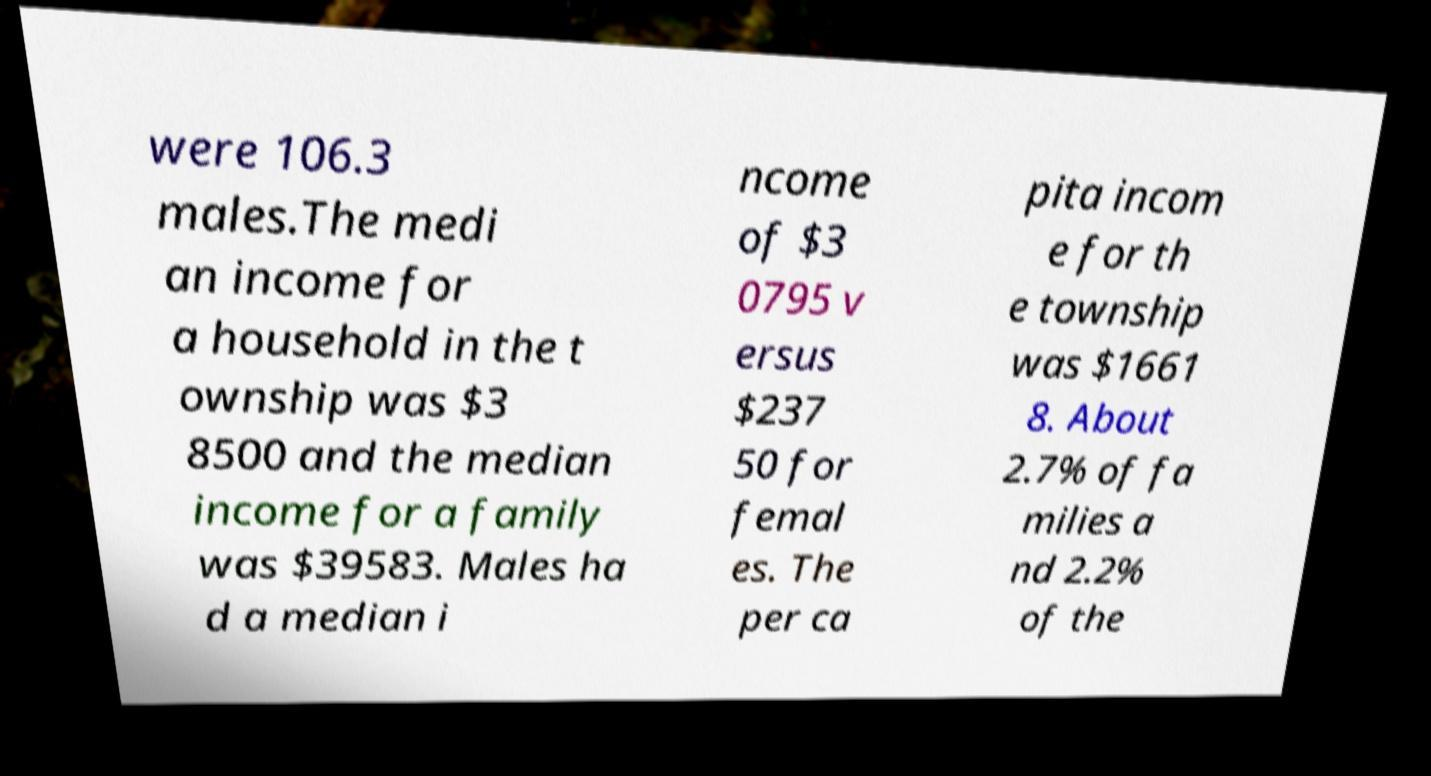I need the written content from this picture converted into text. Can you do that? were 106.3 males.The medi an income for a household in the t ownship was $3 8500 and the median income for a family was $39583. Males ha d a median i ncome of $3 0795 v ersus $237 50 for femal es. The per ca pita incom e for th e township was $1661 8. About 2.7% of fa milies a nd 2.2% of the 